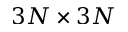<formula> <loc_0><loc_0><loc_500><loc_500>3 N \times 3 N</formula> 